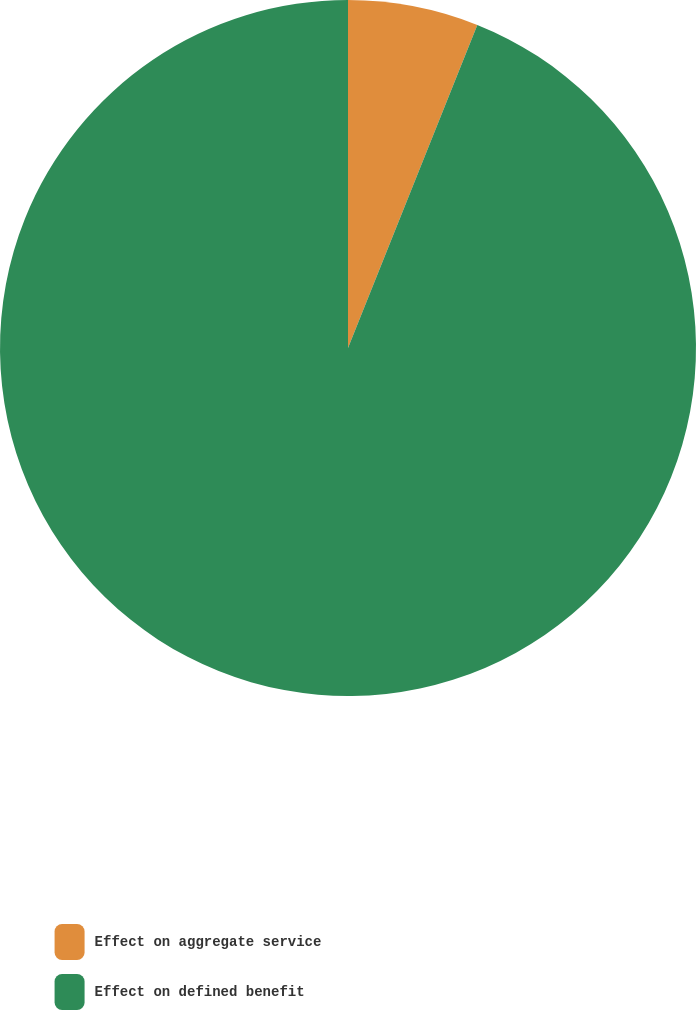<chart> <loc_0><loc_0><loc_500><loc_500><pie_chart><fcel>Effect on aggregate service<fcel>Effect on defined benefit<nl><fcel>6.06%<fcel>93.94%<nl></chart> 